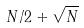Convert formula to latex. <formula><loc_0><loc_0><loc_500><loc_500>N / 2 + \sqrt { N }</formula> 